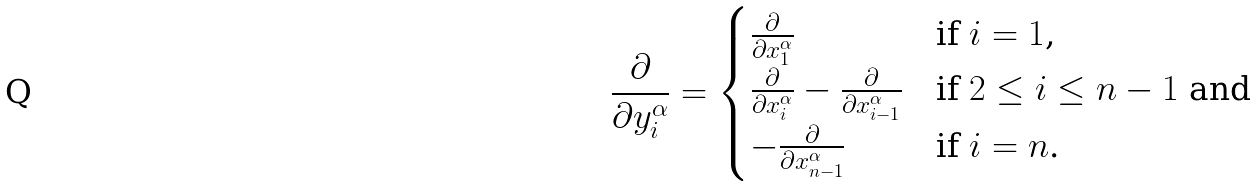<formula> <loc_0><loc_0><loc_500><loc_500>\frac { \partial } { \partial y ^ { \alpha } _ { i } } = \begin{cases} \frac { \partial } { \partial x ^ { \alpha } _ { 1 } } & \text {if $i=1$,} \\ \frac { \partial } { \partial x ^ { \alpha } _ { i } } - \frac { \partial } { \partial x ^ { \alpha } _ { i - 1 } } & \text {if $2\leq i \leq n-1$ and} \\ - \frac { \partial } { \partial x ^ { \alpha } _ { n - 1 } } & \text {if $i=n$.} \\ \end{cases}</formula> 